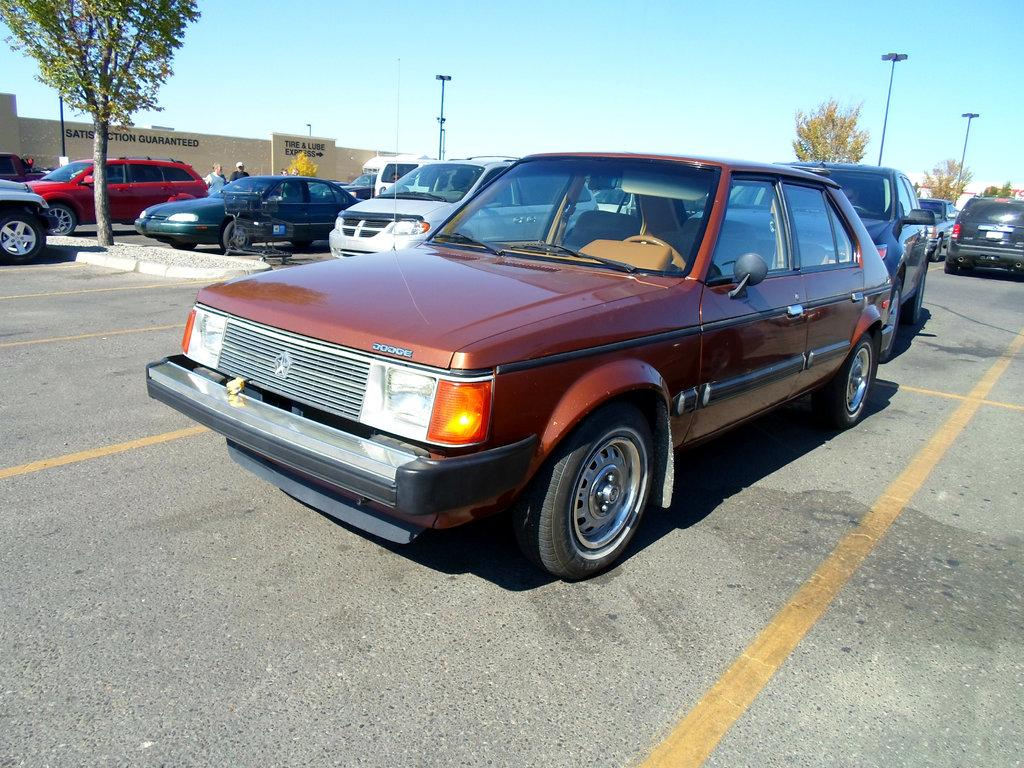What type of vehicles can be seen on the road in the image? There are motor vehicles on the road in the image. What structures are present in the image? There are poles, walls, and trees in the image. Are there any people visible in the image? Yes, there are persons standing in the image. What can be seen in the sky in the image? The sky is visible in the image. What type of chalk is being used by the persons standing in the image? There is no chalk present in the image, and therefore no such activity can be observed. How many baskets are hanging on the walls in the image? There are no baskets present in the image; only poles, walls, and trees are visible. 